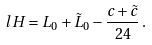<formula> <loc_0><loc_0><loc_500><loc_500>l H = L _ { 0 } + \tilde { L } _ { 0 } - \frac { c + \tilde { c } } { 2 4 } \, .</formula> 